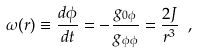<formula> <loc_0><loc_0><loc_500><loc_500>\omega ( r ) \equiv \frac { d \phi } { d t } = - \frac { g _ { 0 \phi } } { g _ { \phi \phi } } = \frac { 2 J } { r ^ { 3 } } \ ,</formula> 